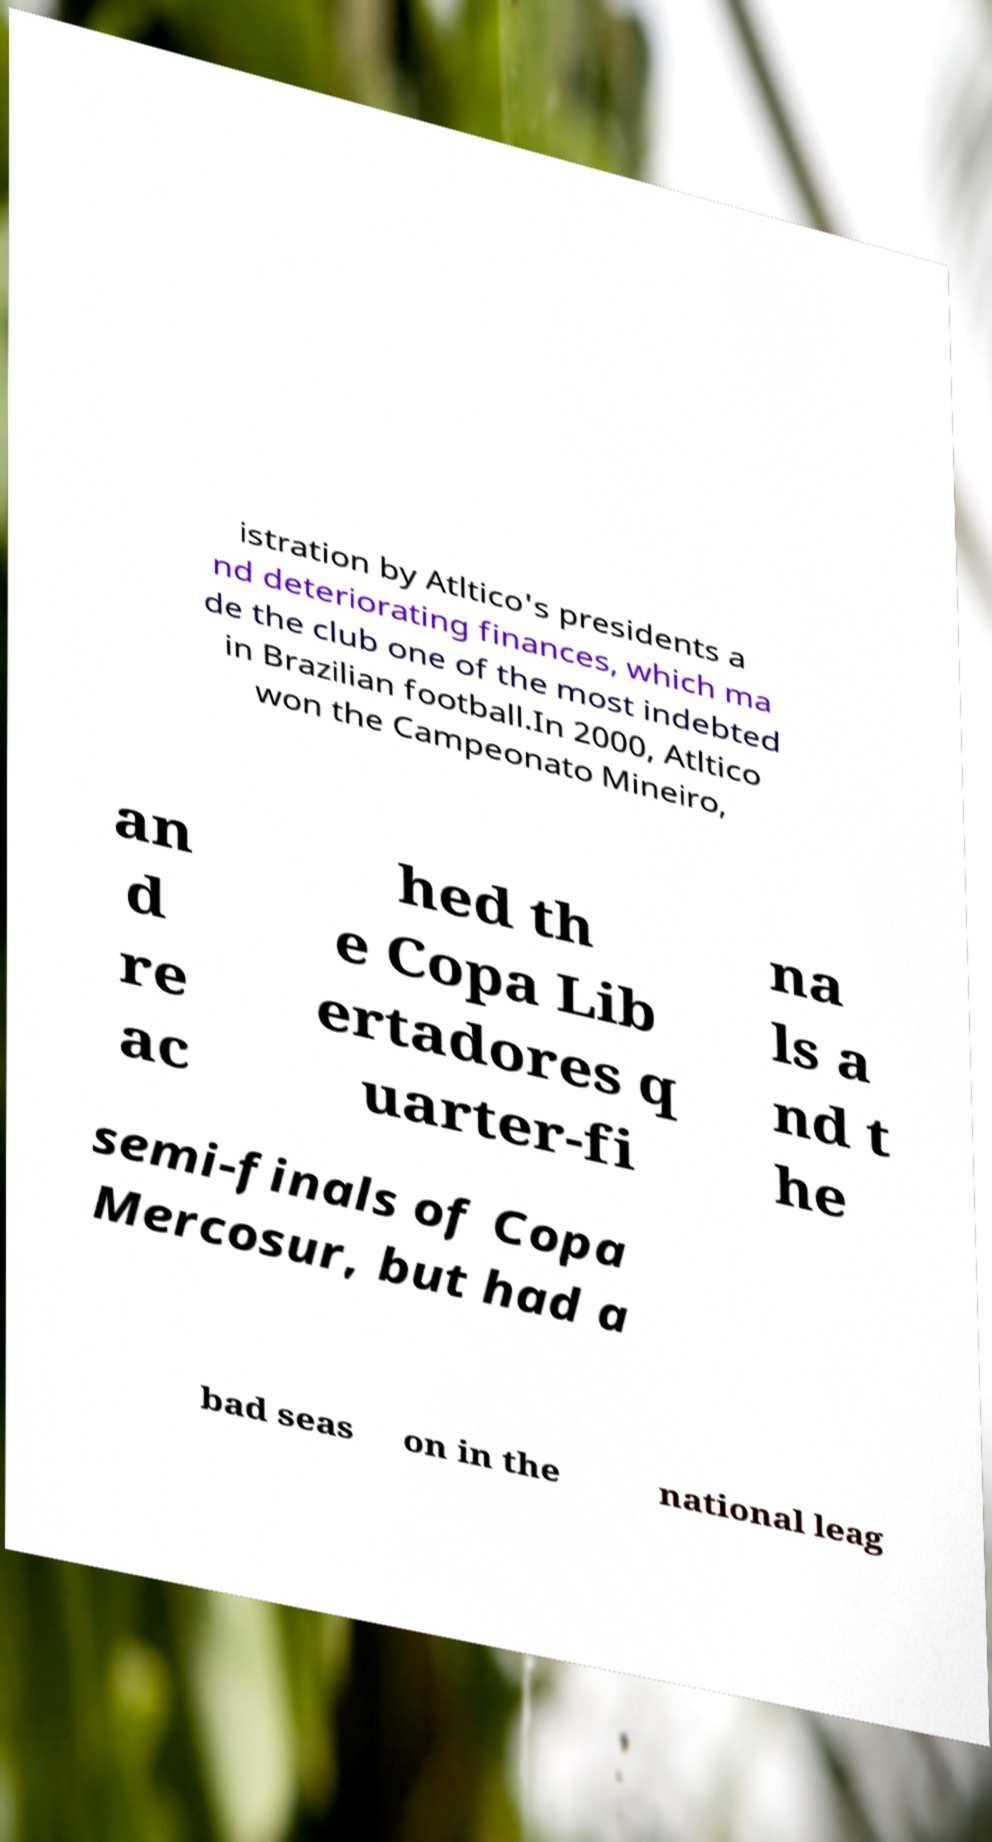Could you assist in decoding the text presented in this image and type it out clearly? istration by Atltico's presidents a nd deteriorating finances, which ma de the club one of the most indebted in Brazilian football.In 2000, Atltico won the Campeonato Mineiro, an d re ac hed th e Copa Lib ertadores q uarter-fi na ls a nd t he semi-finals of Copa Mercosur, but had a bad seas on in the national leag 